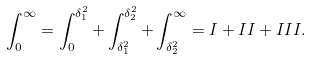<formula> <loc_0><loc_0><loc_500><loc_500>\int _ { 0 } ^ { \infty } = \int _ { 0 } ^ { \delta _ { 1 } ^ { 2 } } + \int _ { \delta _ { 1 } ^ { 2 } } ^ { \delta _ { 2 } ^ { 2 } } + \int _ { \delta _ { 2 } ^ { 2 } } ^ { \infty } = I + I I + I I I .</formula> 